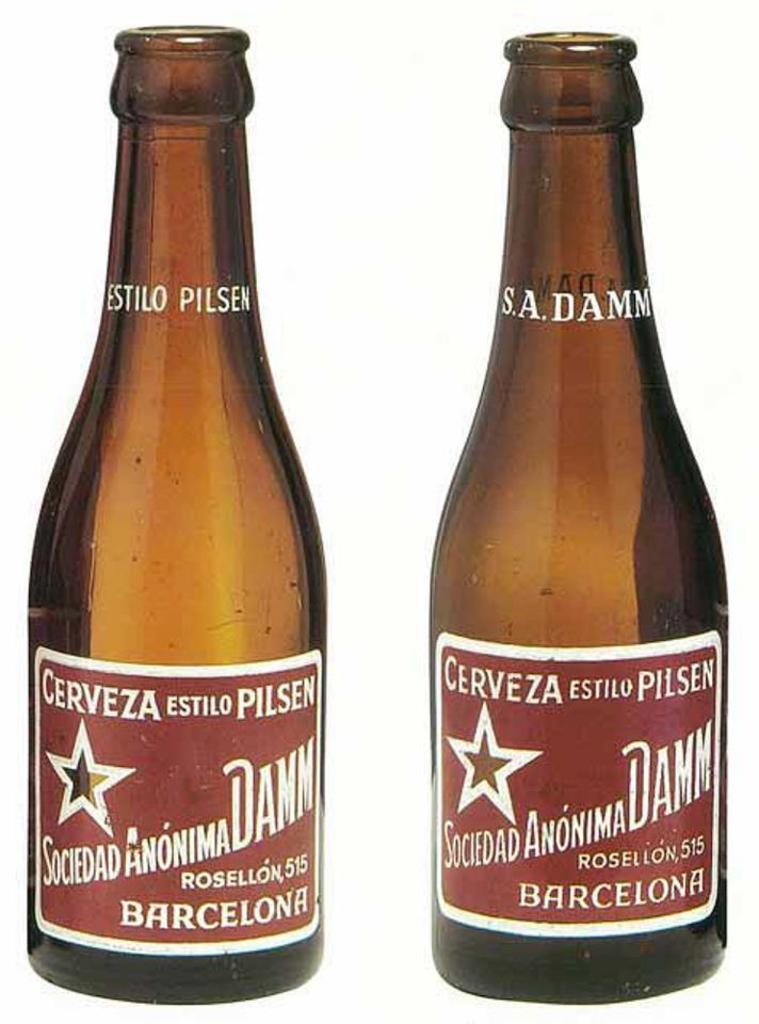<image>
Render a clear and concise summary of the photo. Two empty brown bottles of cerveza from Barcelona. 